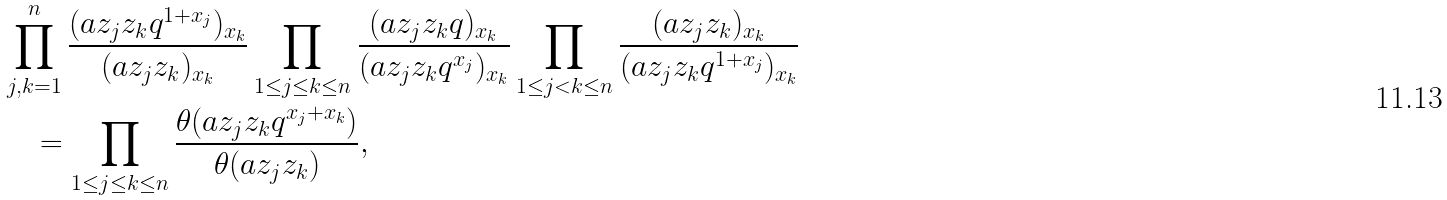<formula> <loc_0><loc_0><loc_500><loc_500>& \prod _ { j , k = 1 } ^ { n } \frac { ( a z _ { j } z _ { k } q ^ { 1 + x _ { j } } ) _ { x _ { k } } } { ( a z _ { j } z _ { k } ) _ { x _ { k } } } \prod _ { 1 \leq j \leq k \leq n } \frac { ( a z _ { j } z _ { k } q ) _ { x _ { k } } } { ( a z _ { j } z _ { k } q ^ { x _ { j } } ) _ { x _ { k } } } \prod _ { 1 \leq j < k \leq n } \frac { ( a z _ { j } z _ { k } ) _ { x _ { k } } } { ( a z _ { j } z _ { k } q ^ { 1 + x _ { j } } ) _ { x _ { k } } } \\ & \quad = \prod _ { 1 \leq j \leq k \leq n } \frac { \theta ( a z _ { j } z _ { k } q ^ { x _ { j } + x _ { k } } ) } { \theta ( a z _ { j } z _ { k } ) } ,</formula> 